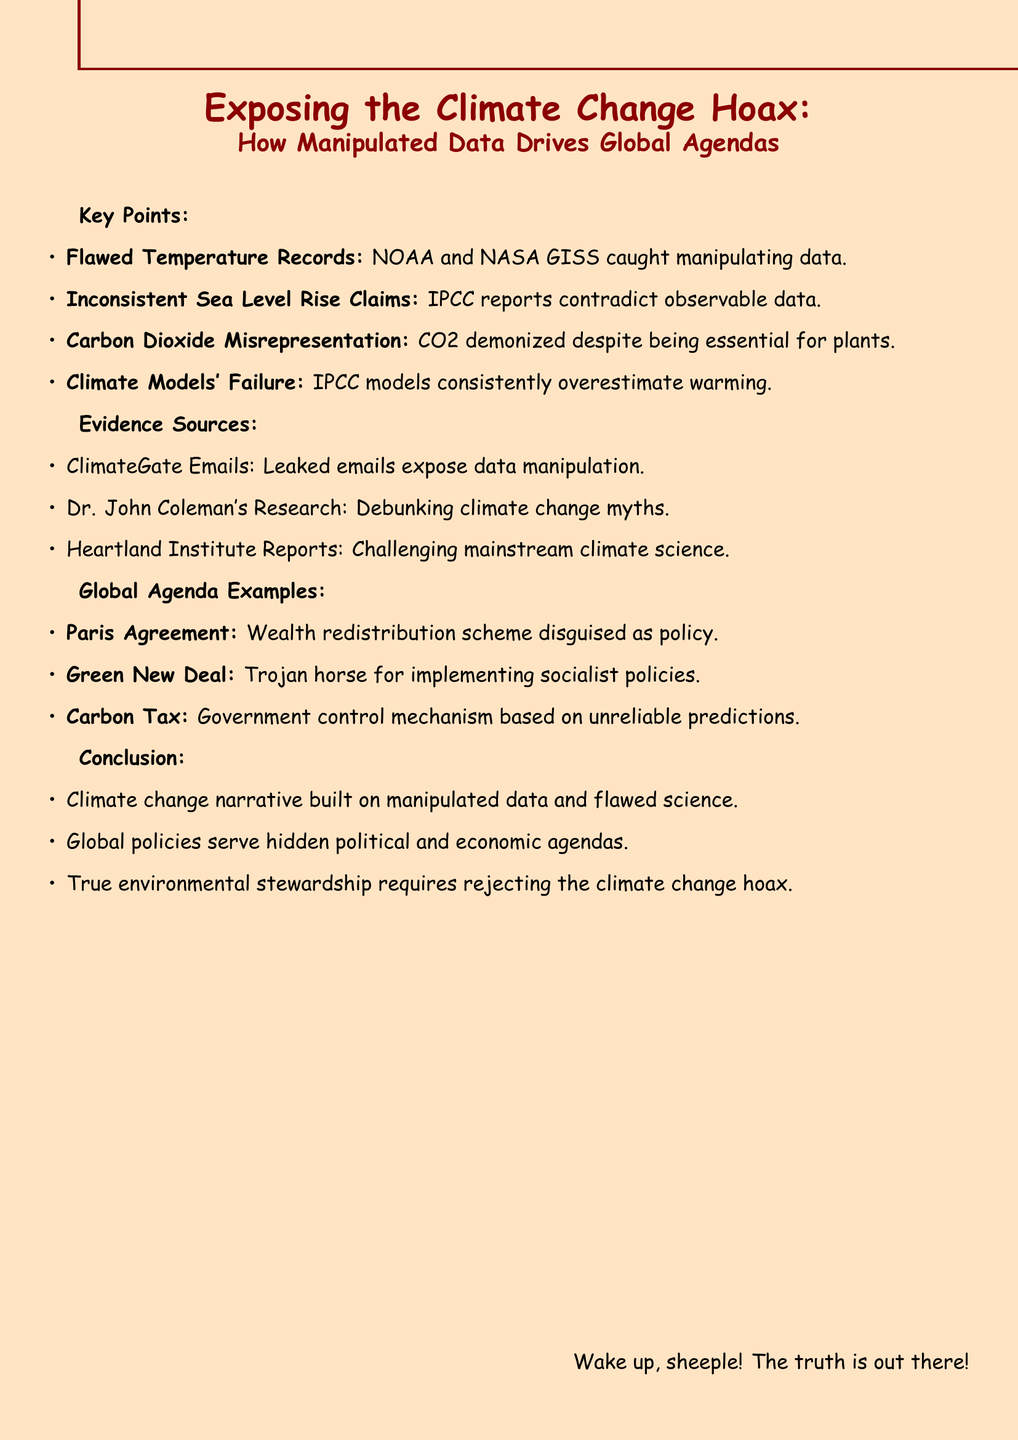What is the title of the memo? The title is what summarizes the main theme and focus of the document, which is provided at the beginning.
Answer: Exposing the Climate Change Hoax: How Manipulated Data Drives Global Agendas Who adjusted historical temperature data? This refers to the agencies implicated in manipulating data within the memo's key points section.
Answer: NOAA and NASA GISS What is the critique of the Paris Agreement? This is found under the "Global Agenda Examples" section, which critiques various political policies based on the document's premise.
Answer: A wealth redistribution scheme disguised as environmental policy What is the evidence source associated with data manipulation? This relates to a specific source mentioned in the "Evidence Sources" section that provides context for the claims made.
Answer: ClimateGate Emails What is the conclusion about the climate change narrative? The conclusion summarizes the overarching message of the memo regarding climate change data and policies.
Answer: Climate change narrative built on manipulated data and flawed science What does the document suggest is essential for true environmental stewardship? This poses a question about a specific point made in the concluding points of the memo regarding environmental responsibility.
Answer: Rejecting the climate change hoax 